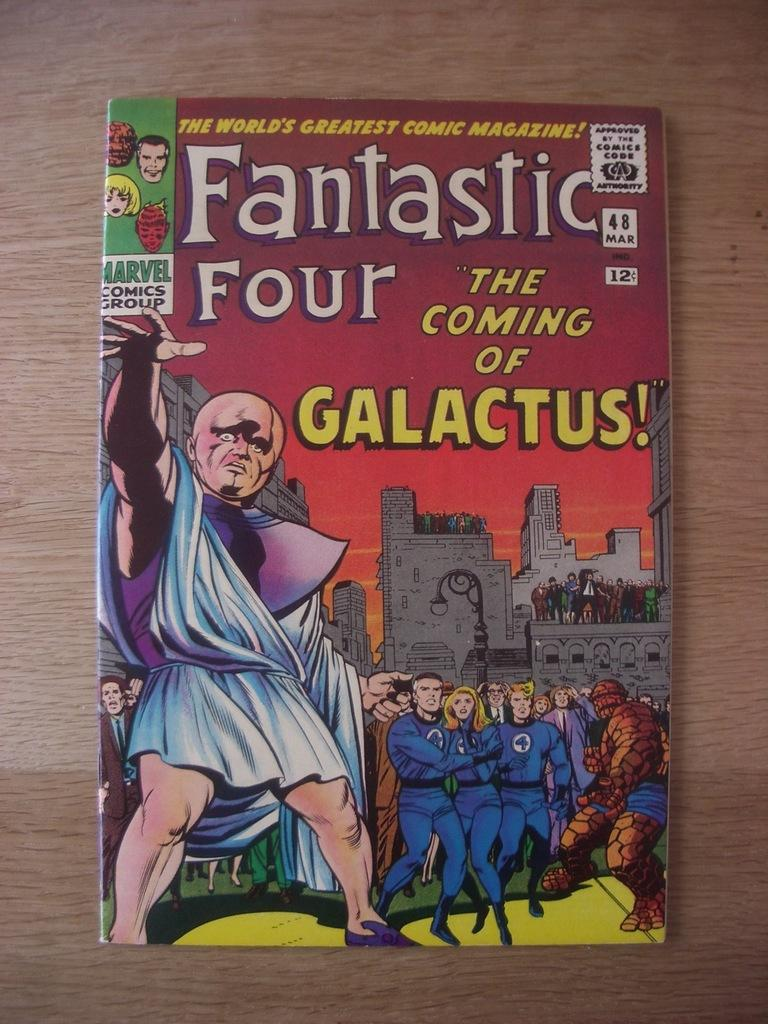Provide a one-sentence caption for the provided image. Fantastic four the coming of galactus magazine on a table. 